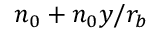Convert formula to latex. <formula><loc_0><loc_0><loc_500><loc_500>n _ { 0 } + n _ { 0 } y / r _ { b }</formula> 